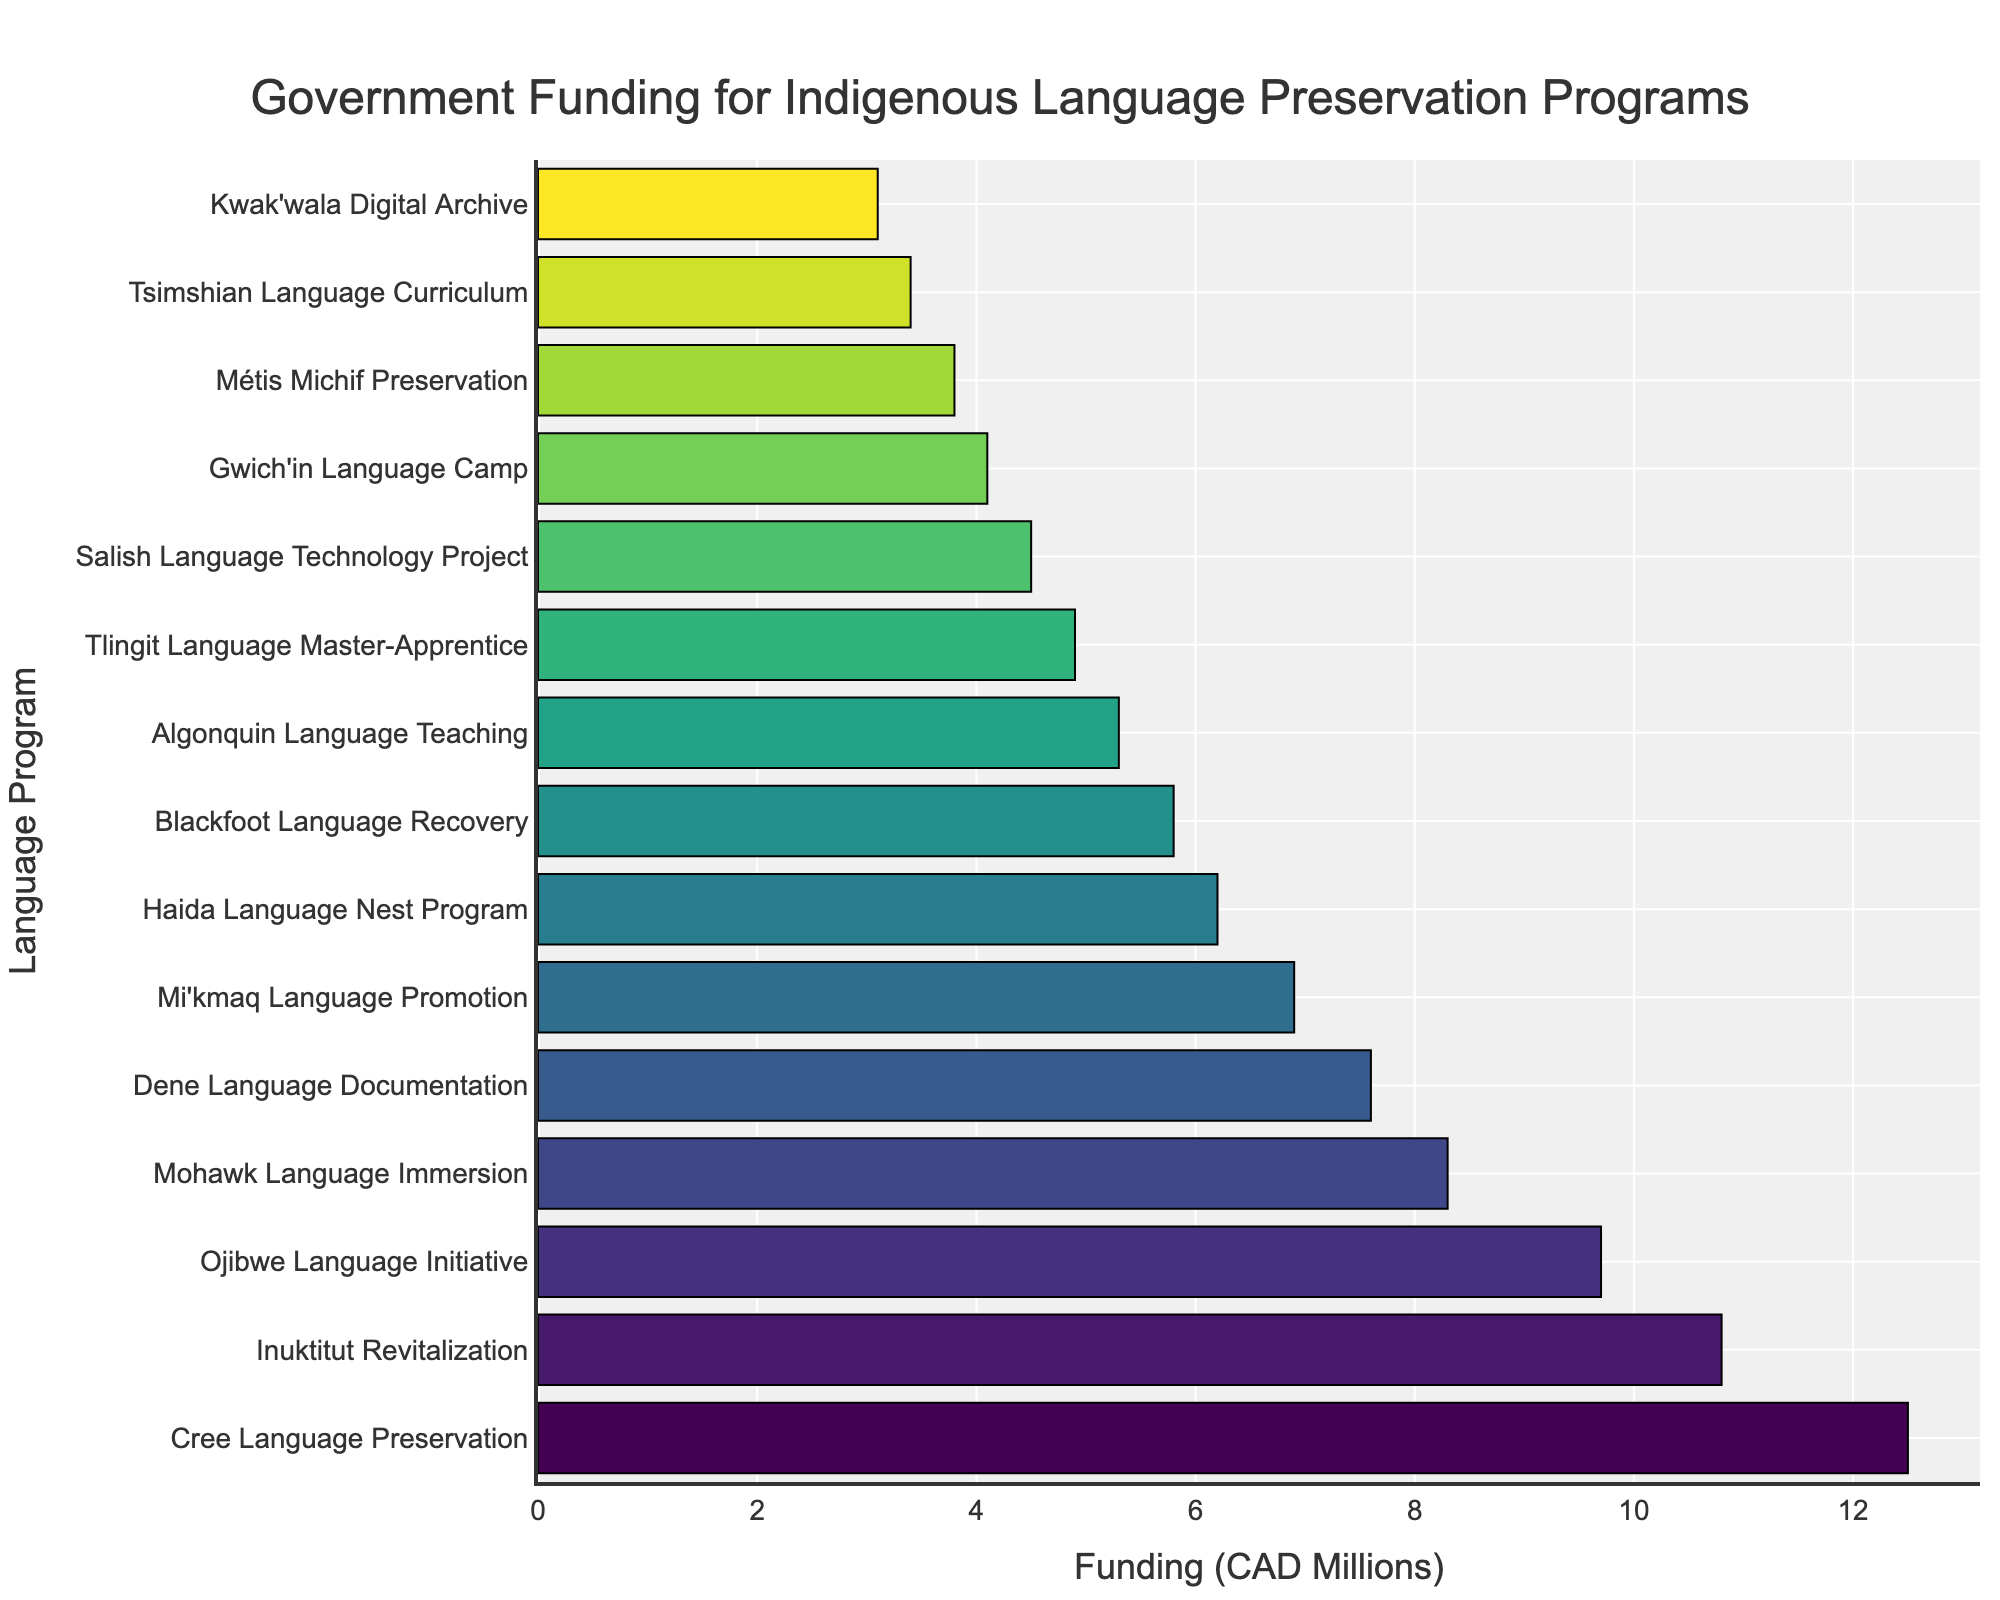What are the top three funded Indigenous language programs? To determine the top three funded programs, locate the three longest bars, since the chart is sorted in descending order based on funding. These programs are Cree Language Preservation, Inuktitut Revitalization, and Ojibwe Language Initiative.
Answer: Cree Language Preservation, Inuktitut Revitalization, Ojibwe Language Initiative Which Indigenous language program received the least funding? To find the program that received the least funding, look for the shortest bar in the chart. This program is Kwak'wala Digital Archive.
Answer: Kwak'wala Digital Archive How much more funding did the Cree Language Preservation program receive compared to the Kwak'wala Digital Archive program? Compare the amount of funding for the Cree Language Preservation program (12.5 million CAD) and the Kwak'wala Digital Archive program (3.1 million CAD). Subtract the latter from the former: 12.5 - 3.1 = 9.4 million CAD.
Answer: 9.4 million CAD What is the total funding for the top five funded programs? Sum the funding amounts for the top five programs: Cree Language Preservation (12.5 million CAD), Inuktitut Revitalization (10.8 million CAD), Ojibwe Language Initiative (9.7 million CAD), Mohawk Language Immersion (8.3 million CAD), and Dene Language Documentation (7.6 million CAD). Total: 12.5 + 10.8 + 9.7 + 8.3 + 7.6 = 48.9 million CAD.
Answer: 48.9 million CAD What is the median funding amount for all the programs? To find the median, first note there are 15 programs. List the funding amounts in ascending order and identify the middle value (8th value): 3.1, 3.4, 3.8, 4.1, 4.5, 4.9, 5.3, 5.8, 6.2, 6.9, 7.6, 8.3, 9.7, 10.8, 12.5. The median value is 5.8 million CAD.
Answer: 5.8 million CAD Which program received more funding: Blackfoot Language Recovery or Haida Language Nest Program? Compare the funding amounts for Blackfoot Language Recovery (5.8 million CAD) and Haida Language Nest Program (6.2 million CAD). Haida Language Nest Program received more funding.
Answer: Haida Language Nest Program How does the funding for the Mi'kmaq Language Promotion compare to the Ojibwe Language Initiative? Compare the funding amounts for Mi'kmaq Language Promotion (6.9 million CAD) and Ojibwe Language Initiative (9.7 million CAD). The Ojibwe Language Initiative received more funding.
Answer: Ojibwe Language Initiative What is the combined funding amount for Salish Language Technology Project and Gwich'in Language Camp? Add the funding amounts for both programs: Salish Language Technology Project (4.5 million CAD) and Gwich'in Language Camp (4.1 million CAD). Total: 4.5 + 4.1 = 8.6 million CAD.
Answer: 8.6 million CAD 